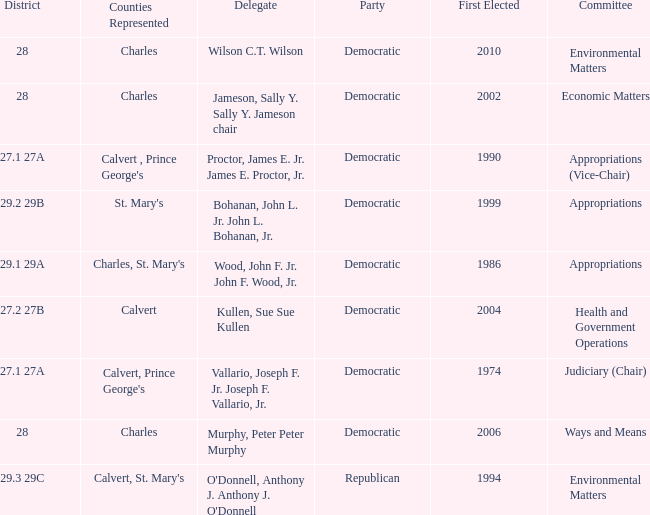When first elected was 2006, who was the delegate? Murphy, Peter Peter Murphy. 